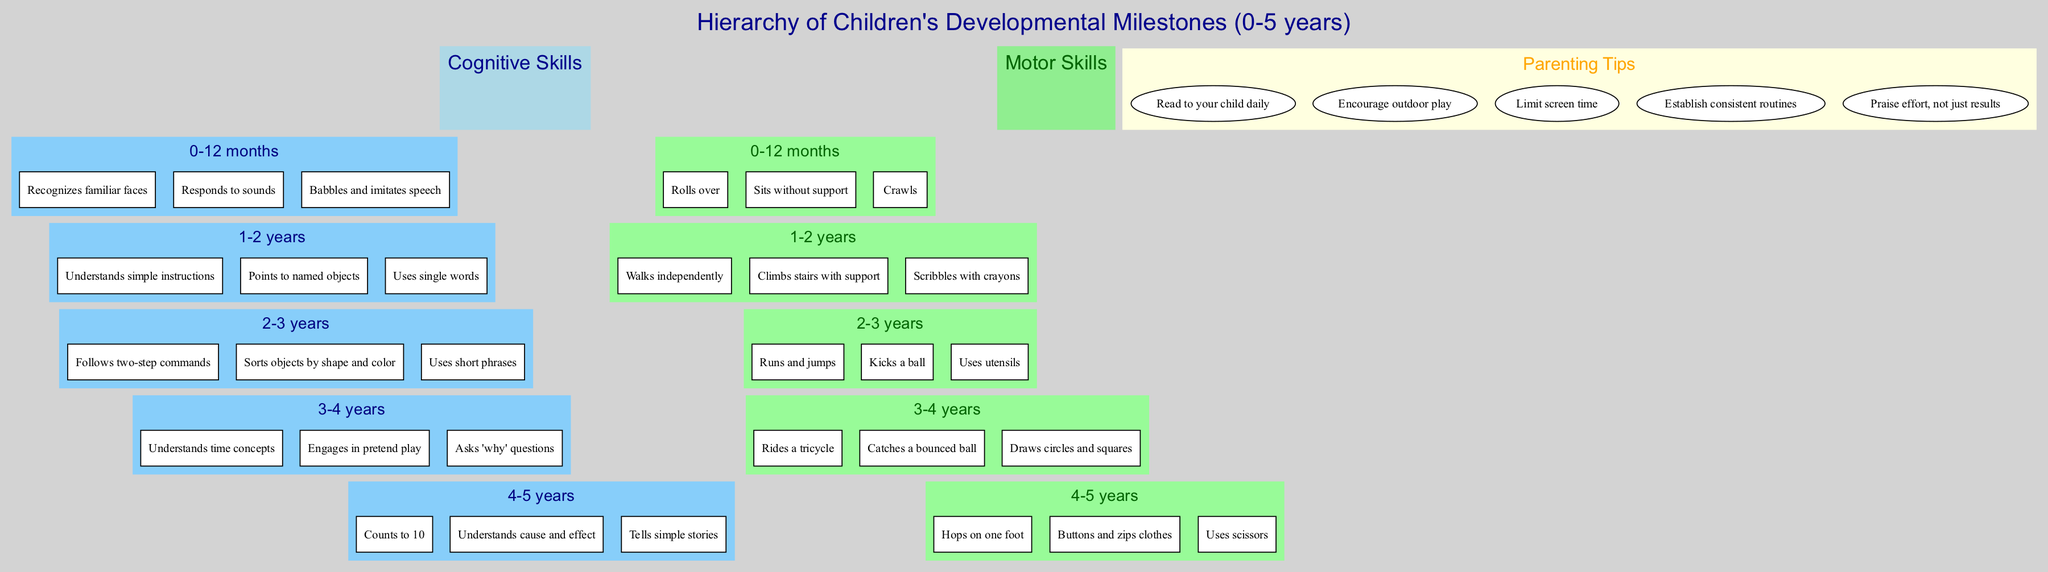What are the skills listed for the age group 2-3 years under cognitive milestones? To find the answer, look at the cognitive milestones section in the diagram and locate the age group "2-3 years." The skills listed for this age group are: "Follows two-step commands," "Sorts objects by shape and color," and "Uses short phrases."
Answer: Follows two-step commands, Sorts objects by shape and color, Uses short phrases How many skills are listed for the age group 1-2 years under motor milestones? Check the motor milestones section of the diagram and focus on the "1-2 years" age group. This group has three skills listed: "Walks independently," "Climbs stairs with support," and "Scribbles with crayons." Therefore, the total number of skills is three.
Answer: 3 What is the relationship between the cognitive milestone "Understands time concepts" and the motor milestone "Rides a tricycle"? The skill "Understands time concepts" is found in the cognitive milestones for the age group "3-4 years," while "Rides a tricycle" is in the motor skills for the same age group. Therefore, both skills are part of the developmental milestones for children between 3 to 4 years.
Answer: Both are for age 3-4 years What is one of the parenting tips provided in the diagram? Look at the parenting tips section of the diagram, where several tips are listed. One example of a parenting tip from this section is "Read to your child daily." Selecting any one of the tips gives the answer.
Answer: Read to your child daily What are the skills associated with the 4-5 years age group under motor skills? To find the answer, refer to the motor milestones section in the diagram and locate the age group "4-5 years." The skills listed are: "Hops on one foot," "Buttons and zips clothes," and "Uses scissors." Therefore, these are the specific skills for this age group.
Answer: Hops on one foot, Buttons and zips clothes, Uses scissors Which category includes the milestone "Counts to 10"? The skill "Counts to 10" is found under cognitive milestones for the age group "4-5 years." Hence, to answer this question, we check the respective skills within the given categories.
Answer: Cognitive Skills How many age groups are represented in the cognitive milestones? By examining the cognitive milestones section in the diagram, we see there are five listed age groups: "0-12 months," "1-2 years," "2-3 years," "3-4 years," and "4-5 years." Thus, the total amount of age groups is five.
Answer: 5 What distinguishes the skills listed for "0-12 months" from those for "4-5 years" under cognitive skills? The cognitive skills for "0-12 months" focus on basic recognition and sound response, such as "Recognizes familiar faces" and "Responds to sounds." In contrast, the skills for "4-5 years" are more advanced, involving counting and storytelling, like "Counts to 10" and "Tells simple stories." The key distinction is the developmental complexity of the skills at each stage.
Answer: Developmental complexity 